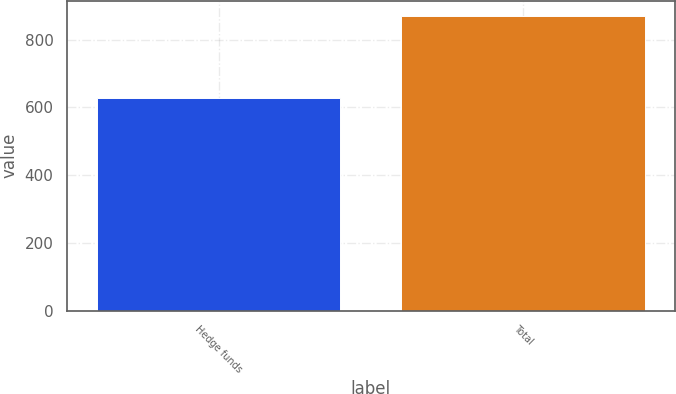<chart> <loc_0><loc_0><loc_500><loc_500><bar_chart><fcel>Hedge funds<fcel>Total<nl><fcel>627<fcel>870<nl></chart> 